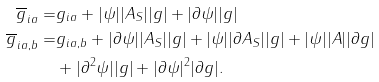<formula> <loc_0><loc_0><loc_500><loc_500>\overline { g } _ { i a } = & g _ { i a } + | \psi | | A _ { S } | | g | + | \partial \psi | | g | \\ \overline { g } _ { i a , b } = & g _ { i a , b } + | \partial \psi | | A _ { S } | | g | + | \psi | | \partial A _ { S } | | g | + | \psi | | A | | \partial g | \\ & + | \partial ^ { 2 } \psi | | g | + | \partial \psi | ^ { 2 } | \partial g | .</formula> 